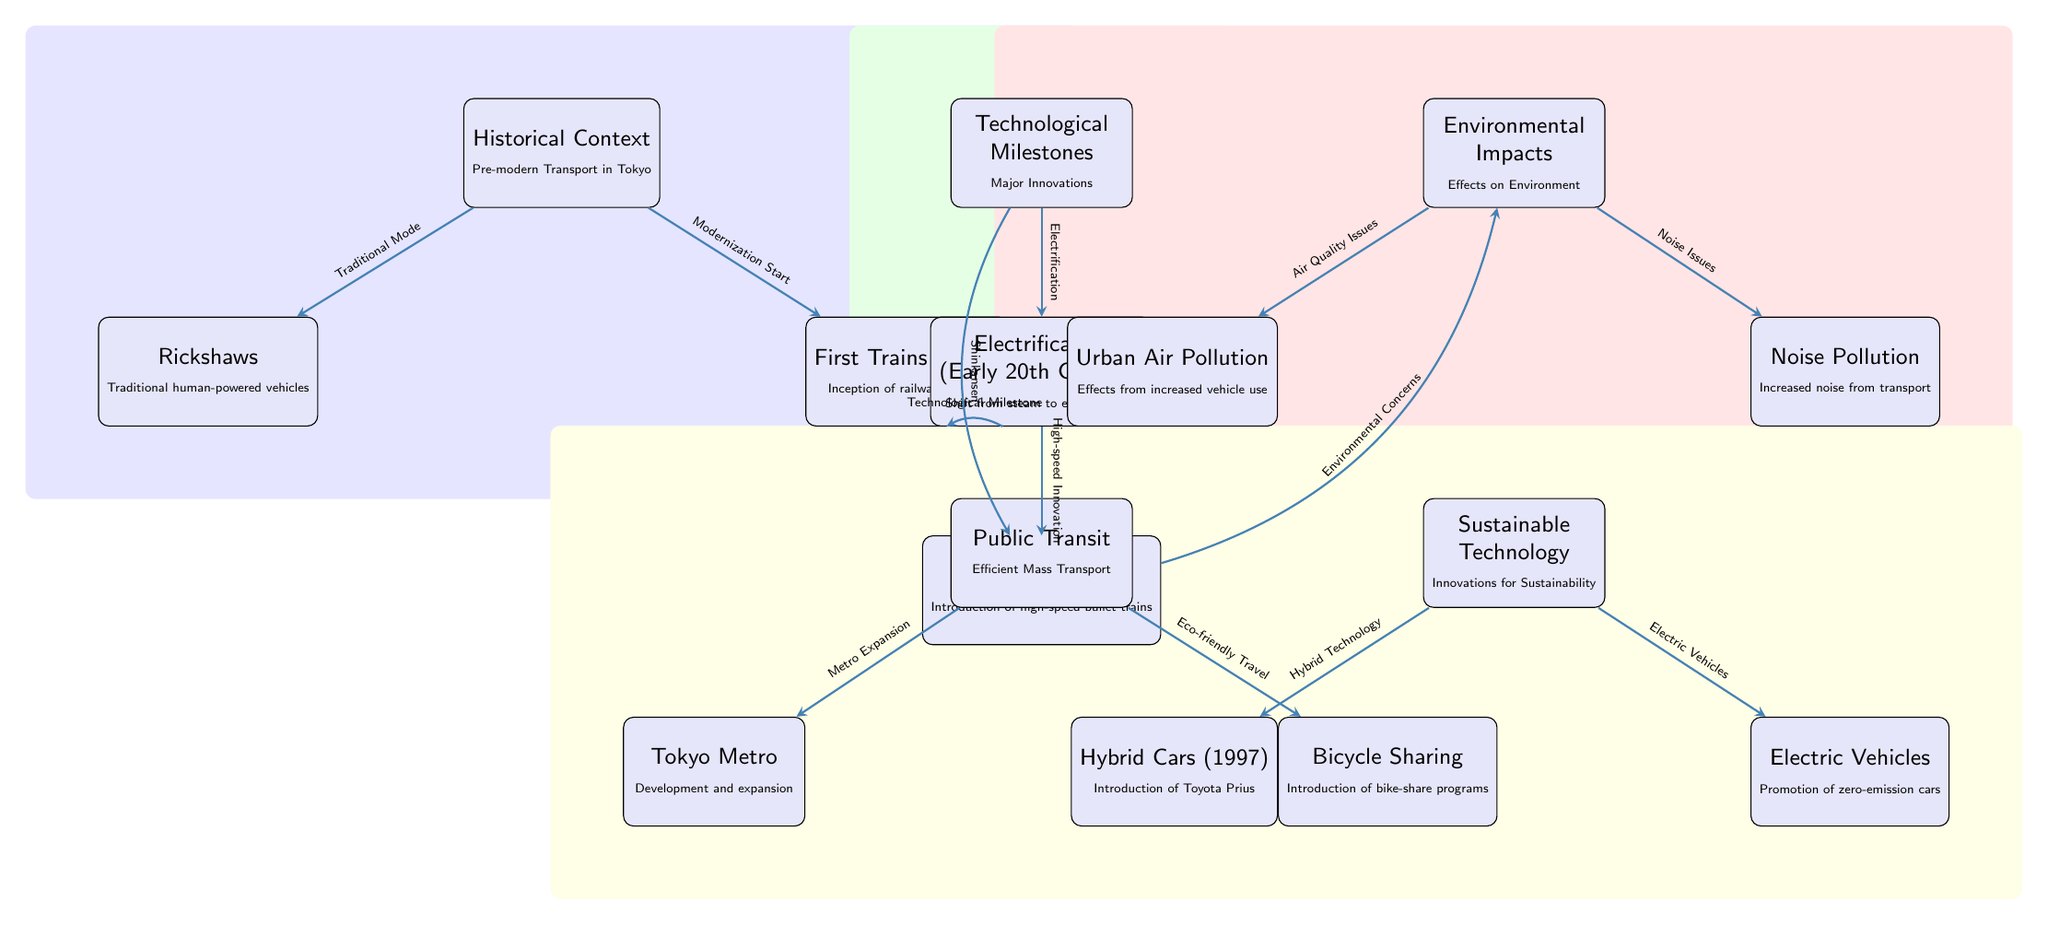What is the first mode of transportation listed in the diagram? The first node in the diagram is "Rickshaws," which is labeled as "Traditional human-powered vehicles."
Answer: Rickshaws How many nodes are included in the "Technological Milestones" section? The "Technological Milestones" node contains three sub-nodes: "Electrification," "Shinkansen (1964)," and "First Trains (1872)," therefore there are three nodes.
Answer: 3 What does the "Electrification" node represent? The "Electrification" node indicates a major shift from steam to electric trains, occurring in the early 20th century.
Answer: Shift from steam to electric trains Which environmental impact is associated with increased vehicle use? The diagram links "Urban Air Pollution" as an environmental impact resulting from increased vehicle use.
Answer: Urban Air Pollution What relationship exists between "Shinkansen" and "Environmental Concerns"? The diagram indicates a flow from "Shinkansen" to "Environmental Concerns," suggesting that the introduction of high-speed trains raised environmental issues related to transportation.
Answer: Shinkansen raises environmental concerns How is "Public Transit" linked to "Bicycle Sharing"? "Public Transit" connects to "Bicycle Sharing" suggesting an element of eco-friendly travel methods like bike-share programs is developed alongside mass transportation initiatives.
Answer: Eco-friendly travel What color is used to represent the "Environmental Impacts" section? The "Environmental Impacts" section is shaded in red, visually distinguishing it from other sections in the diagram.
Answer: Red What milestone is noted as part of the hybrid technology advancements? The introduction of "Hybrid Cars (1997)" is highlighted as a significant milestone in hybrid technology within the diagram.
Answer: Hybrid Cars (1997) Which node is connected to "Noise Pollution"? The diagram indicates that "Noise Pollution" is connected to the "Environmental Impacts" node, pointing to noise as a consequence of transport development.
Answer: Noise Pollution 